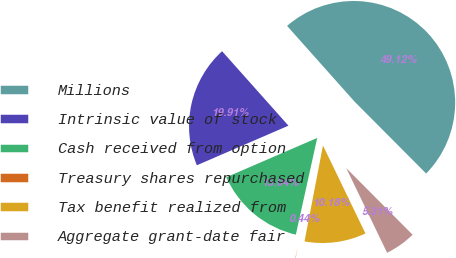<chart> <loc_0><loc_0><loc_500><loc_500><pie_chart><fcel>Millions<fcel>Intrinsic value of stock<fcel>Cash received from option<fcel>Treasury shares repurchased<fcel>Tax benefit realized from<fcel>Aggregate grant-date fair<nl><fcel>49.12%<fcel>19.91%<fcel>15.04%<fcel>0.44%<fcel>10.18%<fcel>5.31%<nl></chart> 